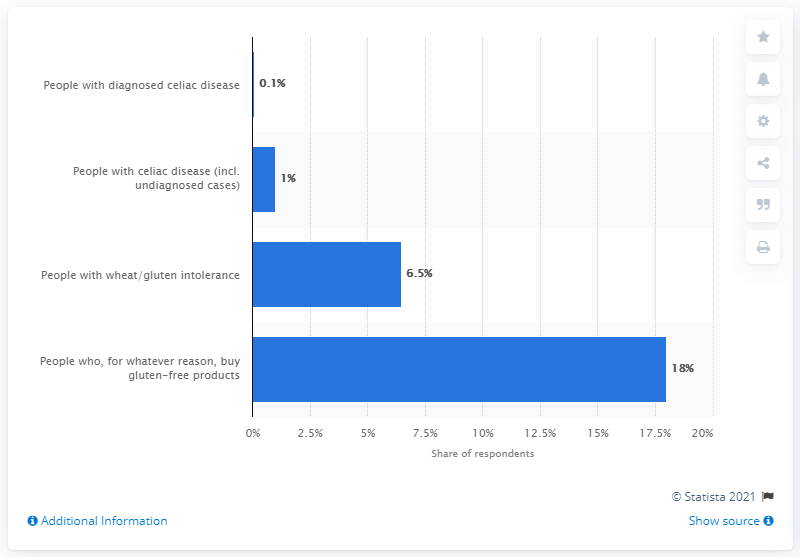List a handful of essential elements in this visual. Approximately 1% of the U.S. population has been diagnosed with celiac disease. 